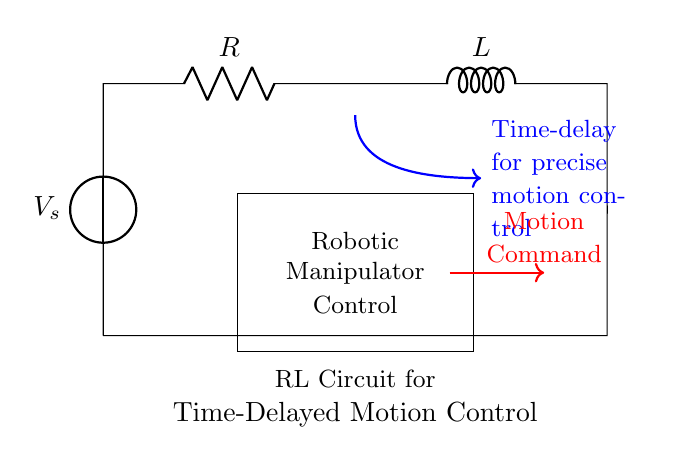What type of circuit is shown? The circuit is a resistor-inductor (RL) circuit, identifiable by the presence of a resistor and an inductor in series with a voltage source.
Answer: Resistor-Inductor What is the role of the voltage source? The voltage source provides electrical energy to the circuit, allowing current to flow through the resistor and inductor, which is crucial for the circuit's operation.
Answer: To provide electrical energy What is indicated by the arrows labeled "Time-delay for precise motion control"? The arrows suggest that the RL circuit is designed to introduce a delay in the motion control of the robotic manipulator, presumably to enhance precision in movement.
Answer: Motion control delay What is the component labeled "R"? The component labeled "R" represents a resistor, which is used to limit the current flow in the circuit and affect the time constant.
Answer: Resistor What effect does the inductor have in this circuit? The inductor provides inductance, which opposes changes in current, thus enabling the time delay characteristic essential for precise motion control in the robotic manipulator.
Answer: Inductance opposes current change What does "Robotic Manipulator Control" signify? This label indicates the purpose of the circuit, suggesting that the RL circuit is integral to the operation and control of a robotic manipulator's movements.
Answer: Purpose of control How does resistance affect the time delay in an RL circuit? The resistance affects the time constant of the RL circuit, with higher resistance resulting in slower current changes and thus a longer time delay for achieving steady-state conditions.
Answer: Slower time response 